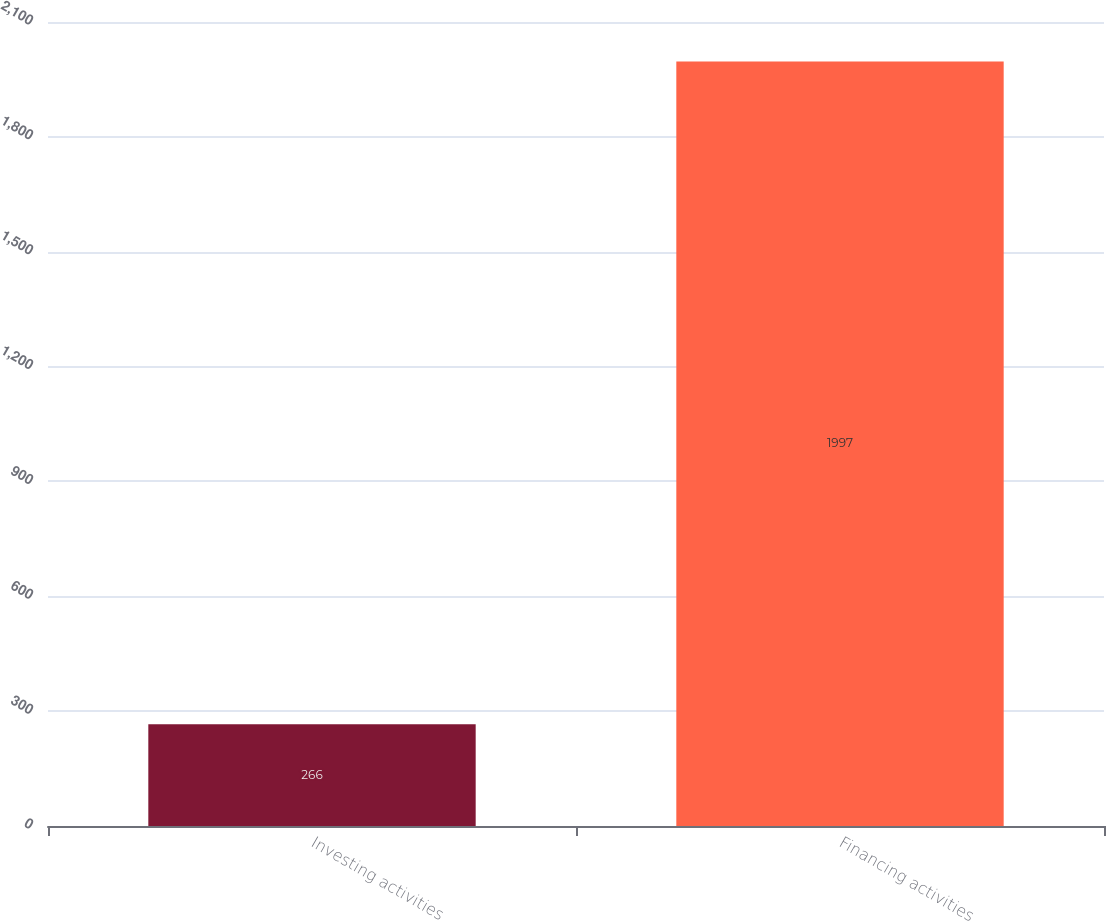Convert chart. <chart><loc_0><loc_0><loc_500><loc_500><bar_chart><fcel>Investing activities<fcel>Financing activities<nl><fcel>266<fcel>1997<nl></chart> 